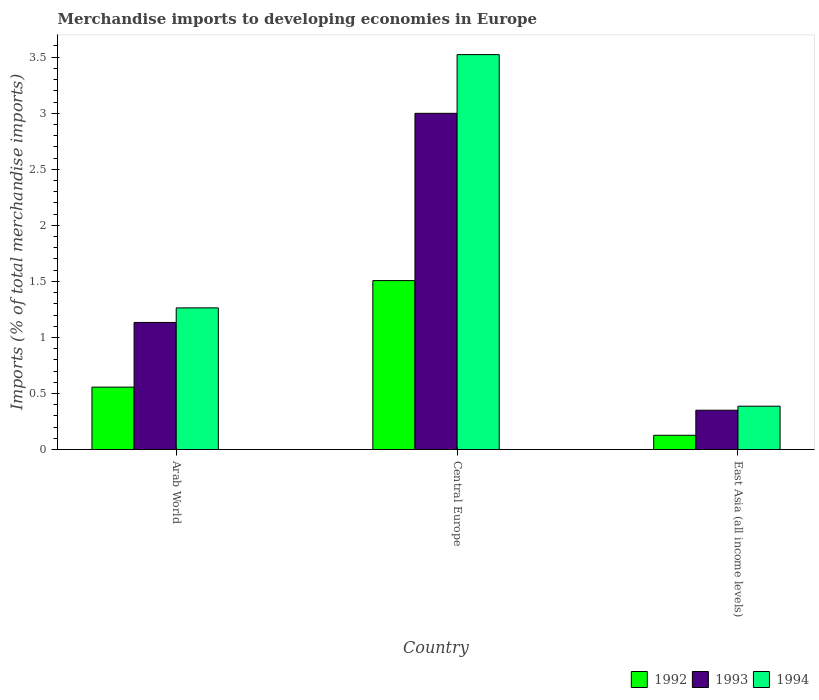What is the label of the 1st group of bars from the left?
Offer a terse response. Arab World. What is the percentage total merchandise imports in 1994 in East Asia (all income levels)?
Provide a short and direct response. 0.39. Across all countries, what is the maximum percentage total merchandise imports in 1993?
Provide a short and direct response. 3. Across all countries, what is the minimum percentage total merchandise imports in 1992?
Your answer should be compact. 0.13. In which country was the percentage total merchandise imports in 1993 maximum?
Give a very brief answer. Central Europe. In which country was the percentage total merchandise imports in 1992 minimum?
Offer a very short reply. East Asia (all income levels). What is the total percentage total merchandise imports in 1992 in the graph?
Offer a terse response. 2.19. What is the difference between the percentage total merchandise imports in 1993 in Arab World and that in East Asia (all income levels)?
Provide a succinct answer. 0.78. What is the difference between the percentage total merchandise imports in 1992 in Arab World and the percentage total merchandise imports in 1993 in Central Europe?
Your answer should be very brief. -2.44. What is the average percentage total merchandise imports in 1992 per country?
Provide a succinct answer. 0.73. What is the difference between the percentage total merchandise imports of/in 1994 and percentage total merchandise imports of/in 1993 in Central Europe?
Keep it short and to the point. 0.52. What is the ratio of the percentage total merchandise imports in 1992 in Arab World to that in Central Europe?
Provide a short and direct response. 0.37. Is the difference between the percentage total merchandise imports in 1994 in Arab World and Central Europe greater than the difference between the percentage total merchandise imports in 1993 in Arab World and Central Europe?
Your response must be concise. No. What is the difference between the highest and the second highest percentage total merchandise imports in 1993?
Offer a terse response. -0.78. What is the difference between the highest and the lowest percentage total merchandise imports in 1993?
Your response must be concise. 2.65. Is the sum of the percentage total merchandise imports in 1992 in Arab World and Central Europe greater than the maximum percentage total merchandise imports in 1993 across all countries?
Your answer should be very brief. No. What does the 1st bar from the left in Central Europe represents?
Your answer should be very brief. 1992. What does the 3rd bar from the right in Arab World represents?
Give a very brief answer. 1992. Is it the case that in every country, the sum of the percentage total merchandise imports in 1993 and percentage total merchandise imports in 1994 is greater than the percentage total merchandise imports in 1992?
Offer a very short reply. Yes. Are all the bars in the graph horizontal?
Your answer should be very brief. No. How many countries are there in the graph?
Give a very brief answer. 3. What is the difference between two consecutive major ticks on the Y-axis?
Your answer should be very brief. 0.5. Are the values on the major ticks of Y-axis written in scientific E-notation?
Offer a terse response. No. How many legend labels are there?
Your response must be concise. 3. How are the legend labels stacked?
Keep it short and to the point. Horizontal. What is the title of the graph?
Give a very brief answer. Merchandise imports to developing economies in Europe. What is the label or title of the X-axis?
Ensure brevity in your answer.  Country. What is the label or title of the Y-axis?
Provide a short and direct response. Imports (% of total merchandise imports). What is the Imports (% of total merchandise imports) in 1992 in Arab World?
Your answer should be very brief. 0.56. What is the Imports (% of total merchandise imports) in 1993 in Arab World?
Offer a very short reply. 1.13. What is the Imports (% of total merchandise imports) in 1994 in Arab World?
Your answer should be very brief. 1.26. What is the Imports (% of total merchandise imports) in 1992 in Central Europe?
Offer a very short reply. 1.51. What is the Imports (% of total merchandise imports) of 1993 in Central Europe?
Offer a terse response. 3. What is the Imports (% of total merchandise imports) of 1994 in Central Europe?
Ensure brevity in your answer.  3.52. What is the Imports (% of total merchandise imports) of 1992 in East Asia (all income levels)?
Ensure brevity in your answer.  0.13. What is the Imports (% of total merchandise imports) of 1993 in East Asia (all income levels)?
Your answer should be compact. 0.35. What is the Imports (% of total merchandise imports) in 1994 in East Asia (all income levels)?
Offer a very short reply. 0.39. Across all countries, what is the maximum Imports (% of total merchandise imports) of 1992?
Your answer should be very brief. 1.51. Across all countries, what is the maximum Imports (% of total merchandise imports) of 1993?
Ensure brevity in your answer.  3. Across all countries, what is the maximum Imports (% of total merchandise imports) in 1994?
Keep it short and to the point. 3.52. Across all countries, what is the minimum Imports (% of total merchandise imports) of 1992?
Offer a very short reply. 0.13. Across all countries, what is the minimum Imports (% of total merchandise imports) in 1993?
Give a very brief answer. 0.35. Across all countries, what is the minimum Imports (% of total merchandise imports) of 1994?
Offer a very short reply. 0.39. What is the total Imports (% of total merchandise imports) of 1992 in the graph?
Your answer should be compact. 2.19. What is the total Imports (% of total merchandise imports) in 1993 in the graph?
Keep it short and to the point. 4.48. What is the total Imports (% of total merchandise imports) in 1994 in the graph?
Offer a very short reply. 5.17. What is the difference between the Imports (% of total merchandise imports) in 1992 in Arab World and that in Central Europe?
Offer a terse response. -0.95. What is the difference between the Imports (% of total merchandise imports) of 1993 in Arab World and that in Central Europe?
Give a very brief answer. -1.87. What is the difference between the Imports (% of total merchandise imports) of 1994 in Arab World and that in Central Europe?
Your answer should be compact. -2.26. What is the difference between the Imports (% of total merchandise imports) in 1992 in Arab World and that in East Asia (all income levels)?
Provide a short and direct response. 0.43. What is the difference between the Imports (% of total merchandise imports) of 1993 in Arab World and that in East Asia (all income levels)?
Your answer should be compact. 0.78. What is the difference between the Imports (% of total merchandise imports) in 1994 in Arab World and that in East Asia (all income levels)?
Make the answer very short. 0.88. What is the difference between the Imports (% of total merchandise imports) in 1992 in Central Europe and that in East Asia (all income levels)?
Make the answer very short. 1.38. What is the difference between the Imports (% of total merchandise imports) of 1993 in Central Europe and that in East Asia (all income levels)?
Provide a succinct answer. 2.65. What is the difference between the Imports (% of total merchandise imports) in 1994 in Central Europe and that in East Asia (all income levels)?
Your answer should be very brief. 3.14. What is the difference between the Imports (% of total merchandise imports) in 1992 in Arab World and the Imports (% of total merchandise imports) in 1993 in Central Europe?
Give a very brief answer. -2.44. What is the difference between the Imports (% of total merchandise imports) in 1992 in Arab World and the Imports (% of total merchandise imports) in 1994 in Central Europe?
Your response must be concise. -2.97. What is the difference between the Imports (% of total merchandise imports) of 1993 in Arab World and the Imports (% of total merchandise imports) of 1994 in Central Europe?
Provide a short and direct response. -2.39. What is the difference between the Imports (% of total merchandise imports) of 1992 in Arab World and the Imports (% of total merchandise imports) of 1993 in East Asia (all income levels)?
Keep it short and to the point. 0.21. What is the difference between the Imports (% of total merchandise imports) of 1992 in Arab World and the Imports (% of total merchandise imports) of 1994 in East Asia (all income levels)?
Ensure brevity in your answer.  0.17. What is the difference between the Imports (% of total merchandise imports) of 1993 in Arab World and the Imports (% of total merchandise imports) of 1994 in East Asia (all income levels)?
Provide a short and direct response. 0.75. What is the difference between the Imports (% of total merchandise imports) of 1992 in Central Europe and the Imports (% of total merchandise imports) of 1993 in East Asia (all income levels)?
Keep it short and to the point. 1.16. What is the difference between the Imports (% of total merchandise imports) of 1992 in Central Europe and the Imports (% of total merchandise imports) of 1994 in East Asia (all income levels)?
Your answer should be very brief. 1.12. What is the difference between the Imports (% of total merchandise imports) of 1993 in Central Europe and the Imports (% of total merchandise imports) of 1994 in East Asia (all income levels)?
Your response must be concise. 2.61. What is the average Imports (% of total merchandise imports) in 1992 per country?
Offer a very short reply. 0.73. What is the average Imports (% of total merchandise imports) in 1993 per country?
Make the answer very short. 1.49. What is the average Imports (% of total merchandise imports) in 1994 per country?
Make the answer very short. 1.72. What is the difference between the Imports (% of total merchandise imports) in 1992 and Imports (% of total merchandise imports) in 1993 in Arab World?
Provide a short and direct response. -0.58. What is the difference between the Imports (% of total merchandise imports) of 1992 and Imports (% of total merchandise imports) of 1994 in Arab World?
Offer a very short reply. -0.71. What is the difference between the Imports (% of total merchandise imports) in 1993 and Imports (% of total merchandise imports) in 1994 in Arab World?
Provide a short and direct response. -0.13. What is the difference between the Imports (% of total merchandise imports) in 1992 and Imports (% of total merchandise imports) in 1993 in Central Europe?
Provide a succinct answer. -1.49. What is the difference between the Imports (% of total merchandise imports) in 1992 and Imports (% of total merchandise imports) in 1994 in Central Europe?
Give a very brief answer. -2.02. What is the difference between the Imports (% of total merchandise imports) of 1993 and Imports (% of total merchandise imports) of 1994 in Central Europe?
Your response must be concise. -0.52. What is the difference between the Imports (% of total merchandise imports) in 1992 and Imports (% of total merchandise imports) in 1993 in East Asia (all income levels)?
Your response must be concise. -0.22. What is the difference between the Imports (% of total merchandise imports) of 1992 and Imports (% of total merchandise imports) of 1994 in East Asia (all income levels)?
Your response must be concise. -0.26. What is the difference between the Imports (% of total merchandise imports) of 1993 and Imports (% of total merchandise imports) of 1994 in East Asia (all income levels)?
Your answer should be very brief. -0.04. What is the ratio of the Imports (% of total merchandise imports) of 1992 in Arab World to that in Central Europe?
Ensure brevity in your answer.  0.37. What is the ratio of the Imports (% of total merchandise imports) in 1993 in Arab World to that in Central Europe?
Your answer should be very brief. 0.38. What is the ratio of the Imports (% of total merchandise imports) of 1994 in Arab World to that in Central Europe?
Provide a short and direct response. 0.36. What is the ratio of the Imports (% of total merchandise imports) of 1992 in Arab World to that in East Asia (all income levels)?
Keep it short and to the point. 4.39. What is the ratio of the Imports (% of total merchandise imports) in 1993 in Arab World to that in East Asia (all income levels)?
Your answer should be compact. 3.23. What is the ratio of the Imports (% of total merchandise imports) in 1994 in Arab World to that in East Asia (all income levels)?
Offer a very short reply. 3.27. What is the ratio of the Imports (% of total merchandise imports) in 1992 in Central Europe to that in East Asia (all income levels)?
Give a very brief answer. 11.88. What is the ratio of the Imports (% of total merchandise imports) of 1993 in Central Europe to that in East Asia (all income levels)?
Ensure brevity in your answer.  8.56. What is the ratio of the Imports (% of total merchandise imports) of 1994 in Central Europe to that in East Asia (all income levels)?
Offer a terse response. 9.11. What is the difference between the highest and the second highest Imports (% of total merchandise imports) of 1992?
Give a very brief answer. 0.95. What is the difference between the highest and the second highest Imports (% of total merchandise imports) in 1993?
Make the answer very short. 1.87. What is the difference between the highest and the second highest Imports (% of total merchandise imports) in 1994?
Ensure brevity in your answer.  2.26. What is the difference between the highest and the lowest Imports (% of total merchandise imports) in 1992?
Keep it short and to the point. 1.38. What is the difference between the highest and the lowest Imports (% of total merchandise imports) of 1993?
Provide a succinct answer. 2.65. What is the difference between the highest and the lowest Imports (% of total merchandise imports) of 1994?
Offer a terse response. 3.14. 